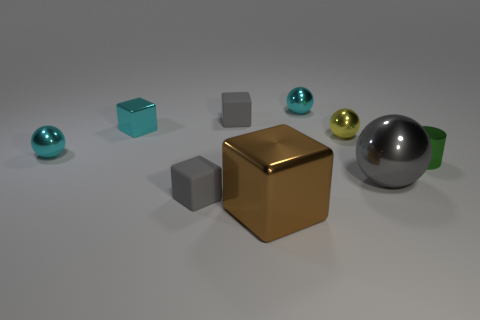Add 1 tiny yellow objects. How many objects exist? 10 Subtract all cylinders. How many objects are left? 8 Subtract 0 blue blocks. How many objects are left? 9 Subtract all large brown metal cubes. Subtract all big brown shiny spheres. How many objects are left? 8 Add 9 big brown metallic things. How many big brown metallic things are left? 10 Add 3 gray metallic things. How many gray metallic things exist? 4 